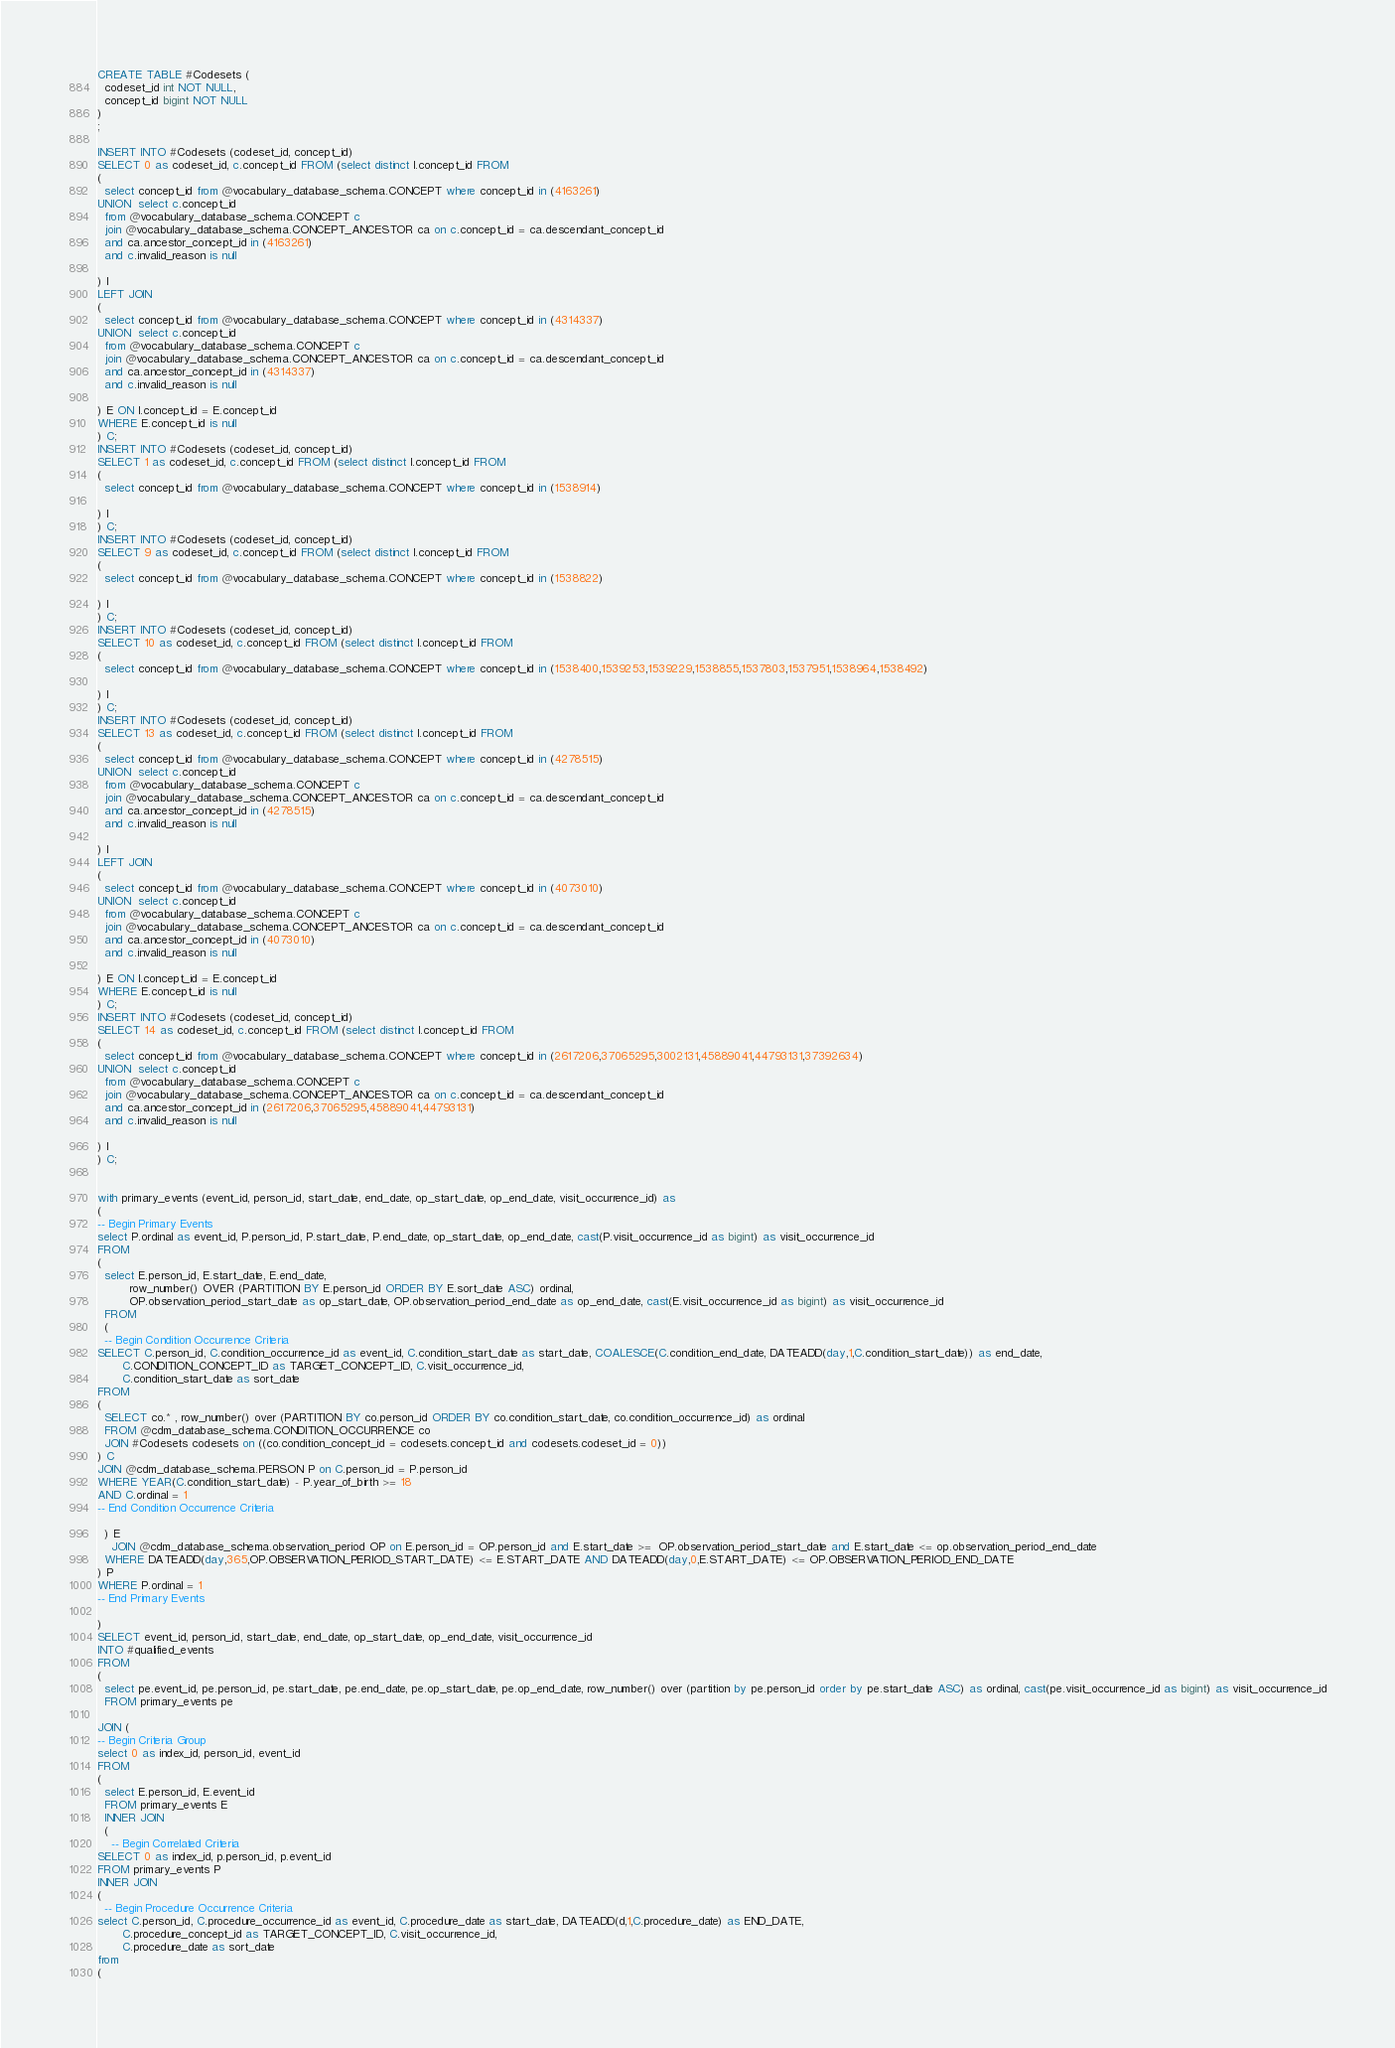<code> <loc_0><loc_0><loc_500><loc_500><_SQL_>CREATE TABLE #Codesets (
  codeset_id int NOT NULL,
  concept_id bigint NOT NULL
)
;

INSERT INTO #Codesets (codeset_id, concept_id)
SELECT 0 as codeset_id, c.concept_id FROM (select distinct I.concept_id FROM
( 
  select concept_id from @vocabulary_database_schema.CONCEPT where concept_id in (4163261)
UNION  select c.concept_id
  from @vocabulary_database_schema.CONCEPT c
  join @vocabulary_database_schema.CONCEPT_ANCESTOR ca on c.concept_id = ca.descendant_concept_id
  and ca.ancestor_concept_id in (4163261)
  and c.invalid_reason is null

) I
LEFT JOIN
(
  select concept_id from @vocabulary_database_schema.CONCEPT where concept_id in (4314337)
UNION  select c.concept_id
  from @vocabulary_database_schema.CONCEPT c
  join @vocabulary_database_schema.CONCEPT_ANCESTOR ca on c.concept_id = ca.descendant_concept_id
  and ca.ancestor_concept_id in (4314337)
  and c.invalid_reason is null

) E ON I.concept_id = E.concept_id
WHERE E.concept_id is null
) C;
INSERT INTO #Codesets (codeset_id, concept_id)
SELECT 1 as codeset_id, c.concept_id FROM (select distinct I.concept_id FROM
( 
  select concept_id from @vocabulary_database_schema.CONCEPT where concept_id in (1538914)

) I
) C;
INSERT INTO #Codesets (codeset_id, concept_id)
SELECT 9 as codeset_id, c.concept_id FROM (select distinct I.concept_id FROM
( 
  select concept_id from @vocabulary_database_schema.CONCEPT where concept_id in (1538822)

) I
) C;
INSERT INTO #Codesets (codeset_id, concept_id)
SELECT 10 as codeset_id, c.concept_id FROM (select distinct I.concept_id FROM
( 
  select concept_id from @vocabulary_database_schema.CONCEPT where concept_id in (1538400,1539253,1539229,1538855,1537803,1537951,1538964,1538492)

) I
) C;
INSERT INTO #Codesets (codeset_id, concept_id)
SELECT 13 as codeset_id, c.concept_id FROM (select distinct I.concept_id FROM
( 
  select concept_id from @vocabulary_database_schema.CONCEPT where concept_id in (4278515)
UNION  select c.concept_id
  from @vocabulary_database_schema.CONCEPT c
  join @vocabulary_database_schema.CONCEPT_ANCESTOR ca on c.concept_id = ca.descendant_concept_id
  and ca.ancestor_concept_id in (4278515)
  and c.invalid_reason is null

) I
LEFT JOIN
(
  select concept_id from @vocabulary_database_schema.CONCEPT where concept_id in (4073010)
UNION  select c.concept_id
  from @vocabulary_database_schema.CONCEPT c
  join @vocabulary_database_schema.CONCEPT_ANCESTOR ca on c.concept_id = ca.descendant_concept_id
  and ca.ancestor_concept_id in (4073010)
  and c.invalid_reason is null

) E ON I.concept_id = E.concept_id
WHERE E.concept_id is null
) C;
INSERT INTO #Codesets (codeset_id, concept_id)
SELECT 14 as codeset_id, c.concept_id FROM (select distinct I.concept_id FROM
( 
  select concept_id from @vocabulary_database_schema.CONCEPT where concept_id in (2617206,37065295,3002131,45889041,44793131,37392634)
UNION  select c.concept_id
  from @vocabulary_database_schema.CONCEPT c
  join @vocabulary_database_schema.CONCEPT_ANCESTOR ca on c.concept_id = ca.descendant_concept_id
  and ca.ancestor_concept_id in (2617206,37065295,45889041,44793131)
  and c.invalid_reason is null

) I
) C;


with primary_events (event_id, person_id, start_date, end_date, op_start_date, op_end_date, visit_occurrence_id) as
(
-- Begin Primary Events
select P.ordinal as event_id, P.person_id, P.start_date, P.end_date, op_start_date, op_end_date, cast(P.visit_occurrence_id as bigint) as visit_occurrence_id
FROM
(
  select E.person_id, E.start_date, E.end_date,
         row_number() OVER (PARTITION BY E.person_id ORDER BY E.sort_date ASC) ordinal,
         OP.observation_period_start_date as op_start_date, OP.observation_period_end_date as op_end_date, cast(E.visit_occurrence_id as bigint) as visit_occurrence_id
  FROM 
  (
  -- Begin Condition Occurrence Criteria
SELECT C.person_id, C.condition_occurrence_id as event_id, C.condition_start_date as start_date, COALESCE(C.condition_end_date, DATEADD(day,1,C.condition_start_date)) as end_date,
       C.CONDITION_CONCEPT_ID as TARGET_CONCEPT_ID, C.visit_occurrence_id,
       C.condition_start_date as sort_date
FROM 
(
  SELECT co.* , row_number() over (PARTITION BY co.person_id ORDER BY co.condition_start_date, co.condition_occurrence_id) as ordinal
  FROM @cdm_database_schema.CONDITION_OCCURRENCE co
  JOIN #Codesets codesets on ((co.condition_concept_id = codesets.concept_id and codesets.codeset_id = 0))
) C
JOIN @cdm_database_schema.PERSON P on C.person_id = P.person_id
WHERE YEAR(C.condition_start_date) - P.year_of_birth >= 18
AND C.ordinal = 1
-- End Condition Occurrence Criteria

  ) E
	JOIN @cdm_database_schema.observation_period OP on E.person_id = OP.person_id and E.start_date >=  OP.observation_period_start_date and E.start_date <= op.observation_period_end_date
  WHERE DATEADD(day,365,OP.OBSERVATION_PERIOD_START_DATE) <= E.START_DATE AND DATEADD(day,0,E.START_DATE) <= OP.OBSERVATION_PERIOD_END_DATE
) P
WHERE P.ordinal = 1
-- End Primary Events

)
SELECT event_id, person_id, start_date, end_date, op_start_date, op_end_date, visit_occurrence_id
INTO #qualified_events
FROM 
(
  select pe.event_id, pe.person_id, pe.start_date, pe.end_date, pe.op_start_date, pe.op_end_date, row_number() over (partition by pe.person_id order by pe.start_date ASC) as ordinal, cast(pe.visit_occurrence_id as bigint) as visit_occurrence_id
  FROM primary_events pe
  
JOIN (
-- Begin Criteria Group
select 0 as index_id, person_id, event_id
FROM
(
  select E.person_id, E.event_id 
  FROM primary_events E
  INNER JOIN
  (
    -- Begin Correlated Criteria
SELECT 0 as index_id, p.person_id, p.event_id
FROM primary_events P
INNER JOIN
(
  -- Begin Procedure Occurrence Criteria
select C.person_id, C.procedure_occurrence_id as event_id, C.procedure_date as start_date, DATEADD(d,1,C.procedure_date) as END_DATE,
       C.procedure_concept_id as TARGET_CONCEPT_ID, C.visit_occurrence_id,
       C.procedure_date as sort_date
from 
(</code> 